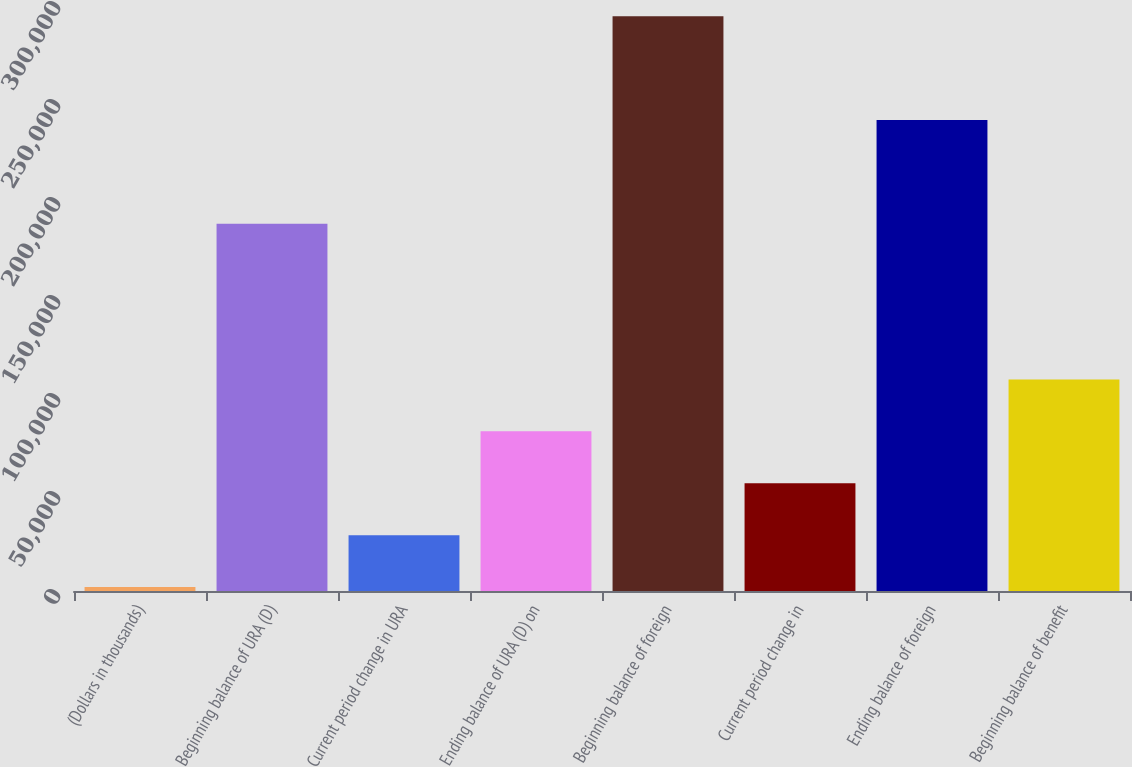<chart> <loc_0><loc_0><loc_500><loc_500><bar_chart><fcel>(Dollars in thousands)<fcel>Beginning balance of URA (D)<fcel>Current period change in URA<fcel>Ending balance of URA (D) on<fcel>Beginning balance of foreign<fcel>Current period change in<fcel>Ending balance of foreign<fcel>Beginning balance of benefit<nl><fcel>2017<fcel>187378<fcel>28497.1<fcel>81457.3<fcel>293298<fcel>54977.2<fcel>240338<fcel>107937<nl></chart> 